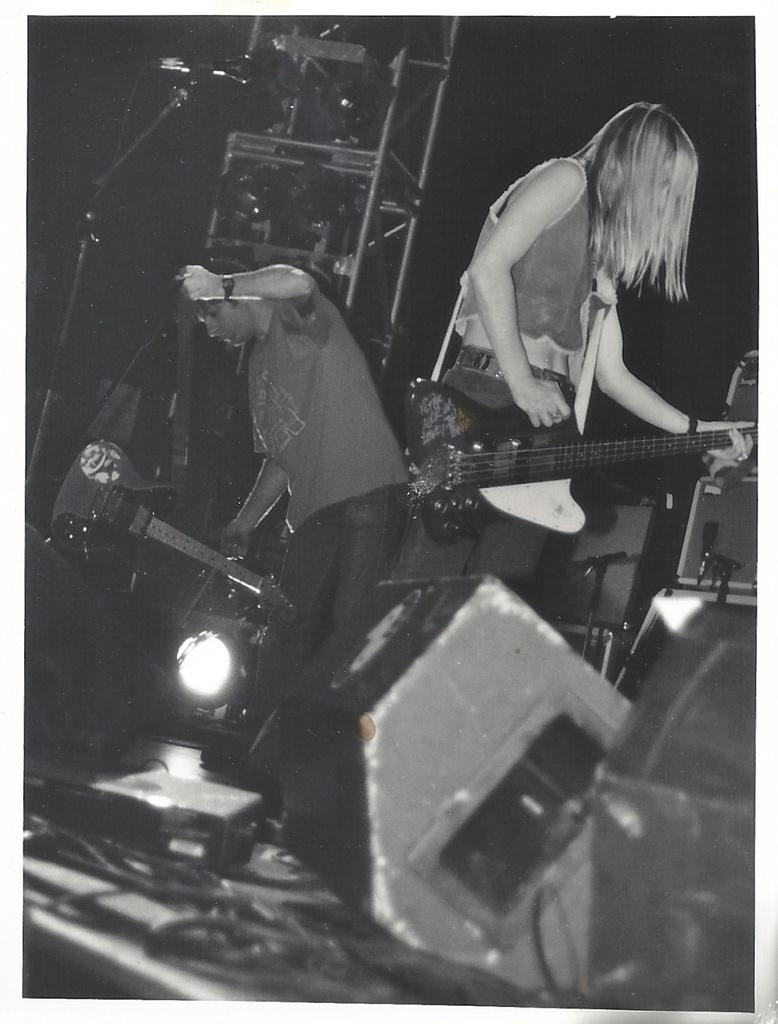Who is present in the image? There is a woman and a man in the image. Where is the woman located in the image? The woman is standing on the right side. What is the woman holding in her hand? The woman is holding a guitar in her hand. Where is the man located in the image? The man is standing on the left side. What type of roof can be seen on the boats in the image? There are no boats or roofs present in the image; it features a woman and a man standing on opposite sides. 